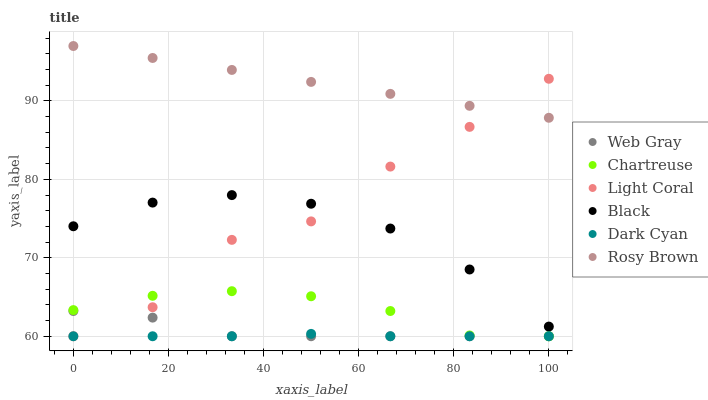Does Dark Cyan have the minimum area under the curve?
Answer yes or no. Yes. Does Rosy Brown have the maximum area under the curve?
Answer yes or no. Yes. Does Light Coral have the minimum area under the curve?
Answer yes or no. No. Does Light Coral have the maximum area under the curve?
Answer yes or no. No. Is Rosy Brown the smoothest?
Answer yes or no. Yes. Is Light Coral the roughest?
Answer yes or no. Yes. Is Light Coral the smoothest?
Answer yes or no. No. Is Rosy Brown the roughest?
Answer yes or no. No. Does Web Gray have the lowest value?
Answer yes or no. Yes. Does Rosy Brown have the lowest value?
Answer yes or no. No. Does Rosy Brown have the highest value?
Answer yes or no. Yes. Does Light Coral have the highest value?
Answer yes or no. No. Is Dark Cyan less than Black?
Answer yes or no. Yes. Is Black greater than Dark Cyan?
Answer yes or no. Yes. Does Dark Cyan intersect Chartreuse?
Answer yes or no. Yes. Is Dark Cyan less than Chartreuse?
Answer yes or no. No. Is Dark Cyan greater than Chartreuse?
Answer yes or no. No. Does Dark Cyan intersect Black?
Answer yes or no. No. 